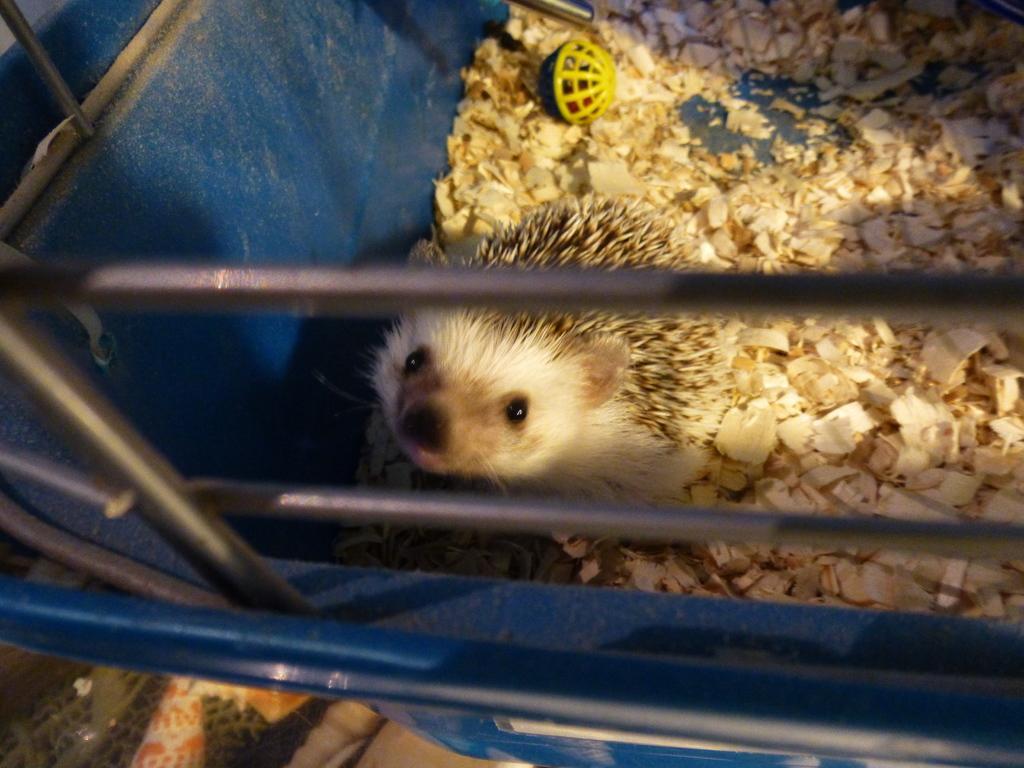In one or two sentences, can you explain what this image depicts? In this image at front there is a mice inside the basket with some stuff in it. 